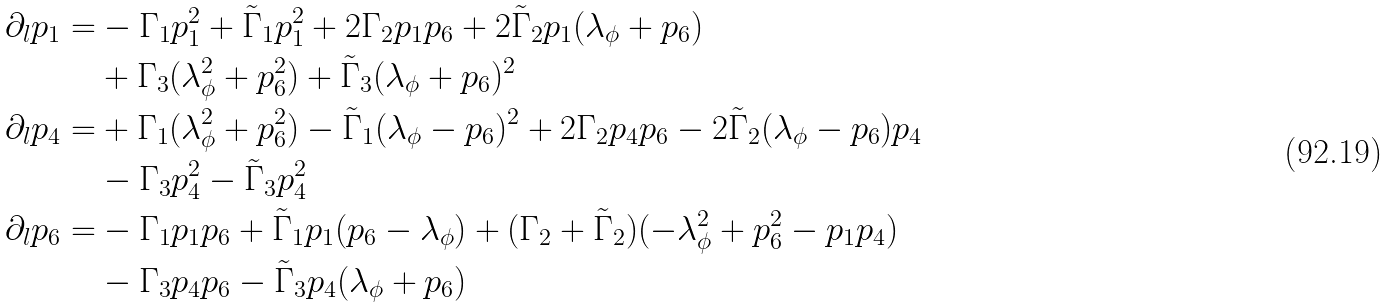<formula> <loc_0><loc_0><loc_500><loc_500>\partial _ { l } p _ { 1 } = & - \Gamma _ { 1 } p _ { 1 } ^ { 2 } + \tilde { \Gamma } _ { 1 } p _ { 1 } ^ { 2 } + 2 \Gamma _ { 2 } p _ { 1 } p _ { 6 } + 2 \tilde { \Gamma } _ { 2 } p _ { 1 } ( \lambda _ { \phi } + p _ { 6 } ) \\ & + \Gamma _ { 3 } ( \lambda _ { \phi } ^ { 2 } + p _ { 6 } ^ { 2 } ) + \tilde { \Gamma } _ { 3 } ( \lambda _ { \phi } + p _ { 6 } ) ^ { 2 } \\ \partial _ { l } p _ { 4 } = & + \Gamma _ { 1 } ( \lambda _ { \phi } ^ { 2 } + p _ { 6 } ^ { 2 } ) - \tilde { \Gamma } _ { 1 } ( \lambda _ { \phi } - p _ { 6 } ) ^ { 2 } + 2 \Gamma _ { 2 } p _ { 4 } p _ { 6 } - 2 \tilde { \Gamma } _ { 2 } ( \lambda _ { \phi } - p _ { 6 } ) p _ { 4 } \\ & - \Gamma _ { 3 } p _ { 4 } ^ { 2 } - \tilde { \Gamma } _ { 3 } p _ { 4 } ^ { 2 } \\ \partial _ { l } p _ { 6 } = & - \Gamma _ { 1 } p _ { 1 } p _ { 6 } + \tilde { \Gamma } _ { 1 } p _ { 1 } ( p _ { 6 } - \lambda _ { \phi } ) + ( \Gamma _ { 2 } + \tilde { \Gamma } _ { 2 } ) ( - \lambda _ { \phi } ^ { 2 } + p _ { 6 } ^ { 2 } - p _ { 1 } p _ { 4 } ) \\ & - \Gamma _ { 3 } p _ { 4 } p _ { 6 } - \tilde { \Gamma } _ { 3 } p _ { 4 } ( \lambda _ { \phi } + p _ { 6 } )</formula> 